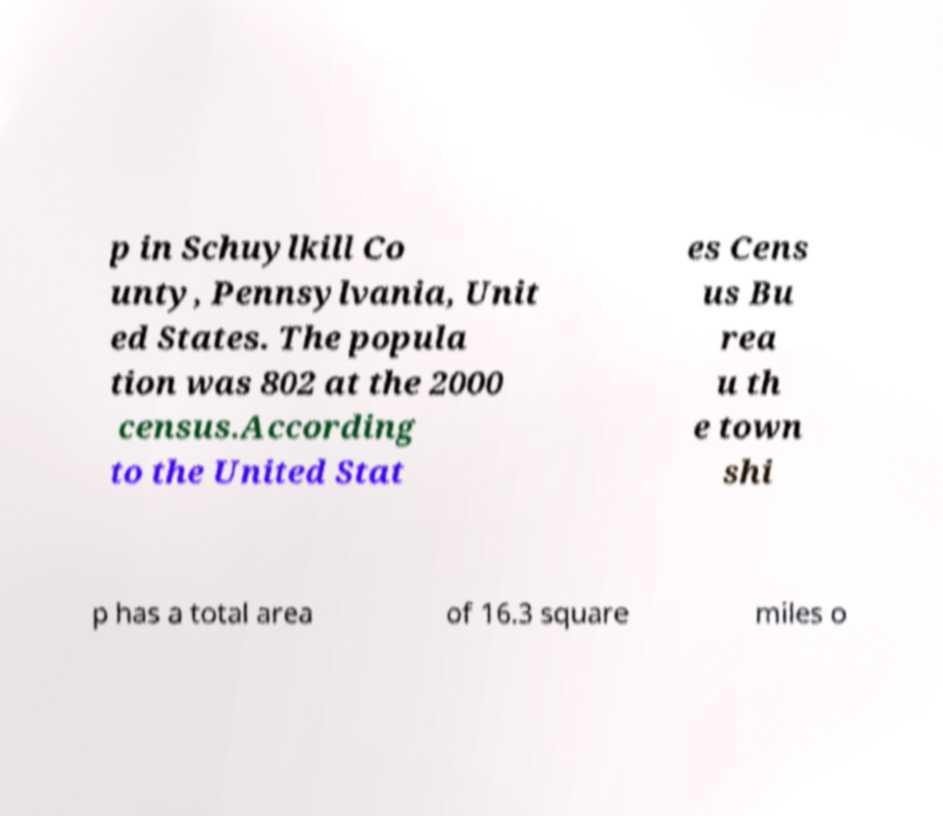What messages or text are displayed in this image? I need them in a readable, typed format. p in Schuylkill Co unty, Pennsylvania, Unit ed States. The popula tion was 802 at the 2000 census.According to the United Stat es Cens us Bu rea u th e town shi p has a total area of 16.3 square miles o 